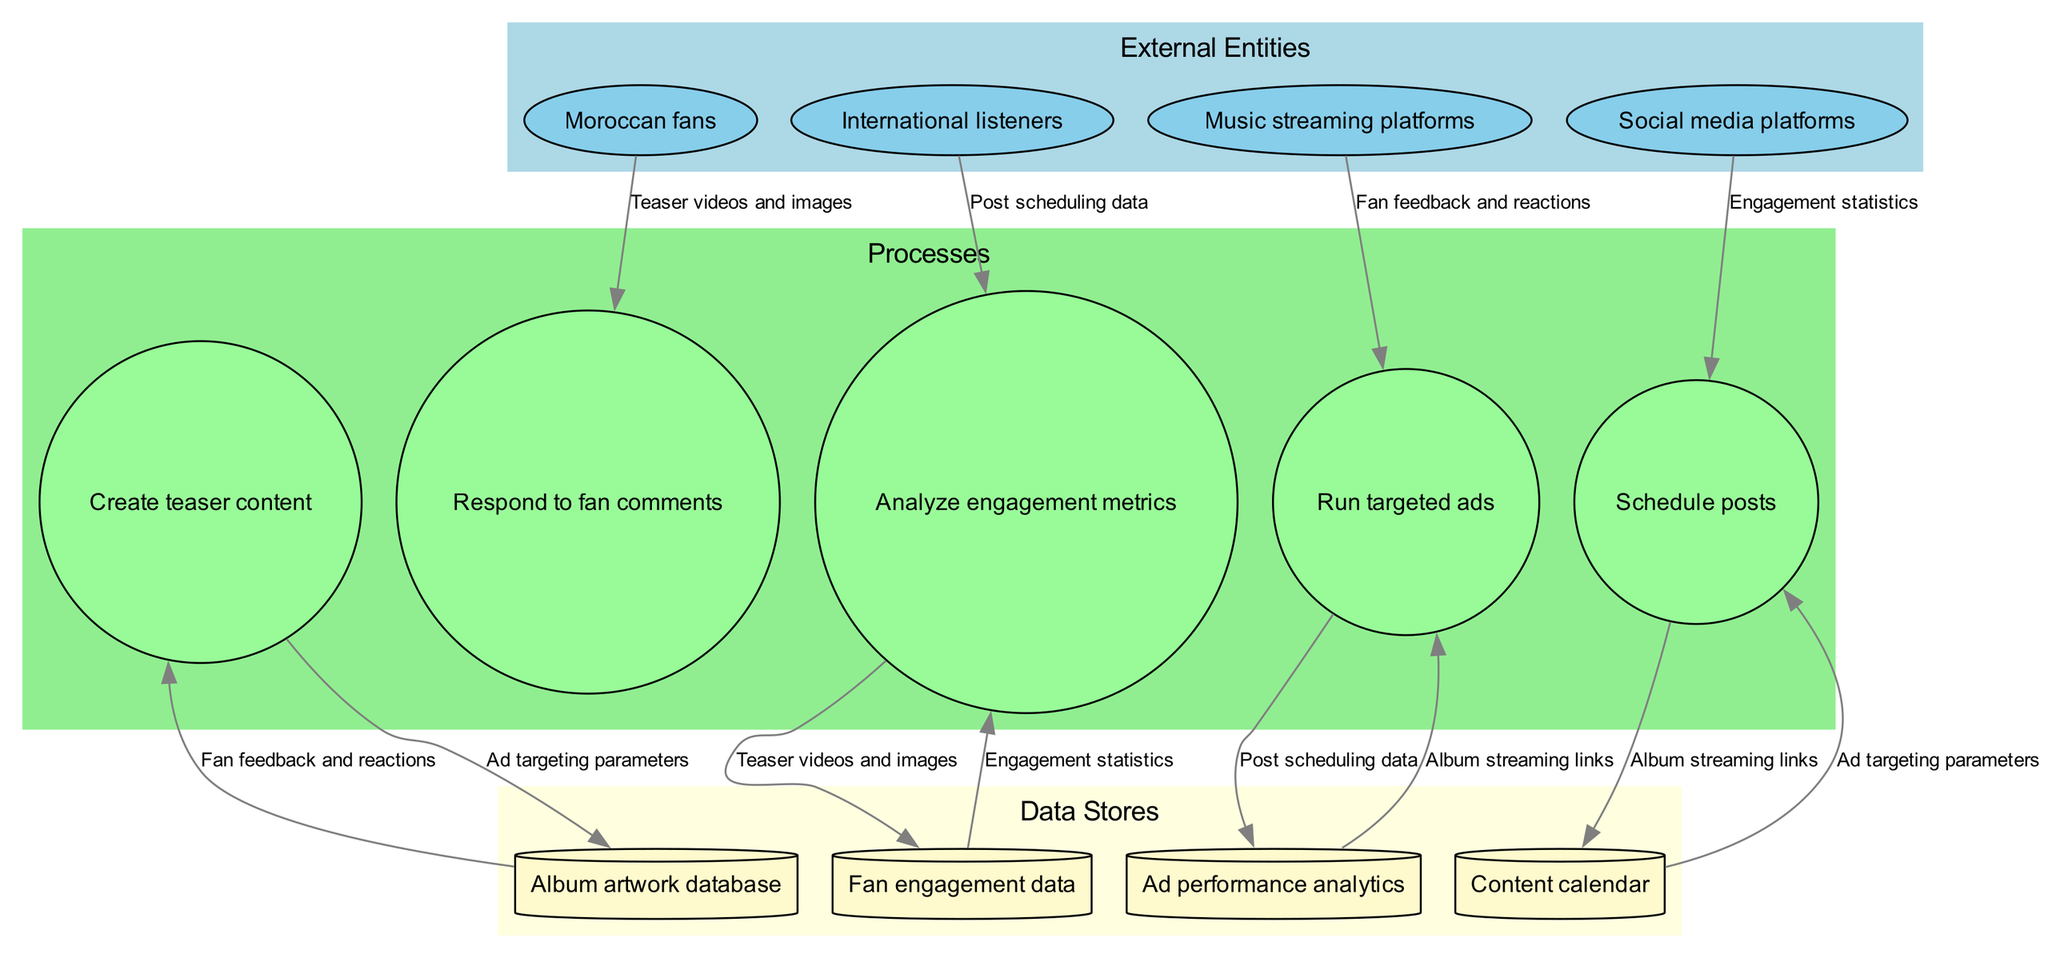What are the external entities present in the diagram? The external entities listed in the diagram include Moroccan fans, International listeners, Music streaming platforms, and Social media platforms.
Answer: Moroccan fans, International listeners, Music streaming platforms, Social media platforms How many processes are shown in the diagram? The diagram shows five processes: Create teaser content, Schedule posts, Analyze engagement metrics, Respond to fan comments, and Run targeted ads. Counting these gives a total of five processes.
Answer: 5 What data flows from Music streaming platforms? Following the flow from Music streaming platforms leads to the "Run targeted ads" process, indicating that the specific data flow involved is related to targeted advertising.
Answer: Run targeted ads What is the purpose of the 'Content calendar' data store? The data store named 'Content calendar' is used to manage the schedule for posts. Following the edges in the diagram confirms that it connects to the 'Schedule posts' process.
Answer: Schedule posts Which process is responsible for analyzing fan engagement metrics? The process labeled 'Analyze engagement metrics' is designated for this purpose. By examining the edges, we can confirm that this process connects to fan engagement data received from the 'Fan engagement data' data store.
Answer: Analyze engagement metrics How many data stores are involved in the diagram? The diagram features four data stores: Album artwork database, Fan engagement data, Content calendar, and Ad performance analytics. Counting these gives a total of four data stores.
Answer: 4 What do Moroccan fans directly influence in the diagram? The flow shows that Moroccan fans are directly influencing the 'Respond to fan comments' process, indicating their engagement results in feedback management.
Answer: Respond to fan comments Which external entity provides feedback for engagement metrics? The 'International listeners' external entity is the one that contributes feedback used in the 'Analyze engagement metrics' process, as indicated by the edges that connect these entities and processes.
Answer: International listeners What type of data does 'Engagement statistics' represent in the flow? The 'Engagement statistics' data flow represents the analytical results gained from the process of analyzing fan engagement, showing relationships between fan feedback and metrics used.
Answer: Engagement statistics 